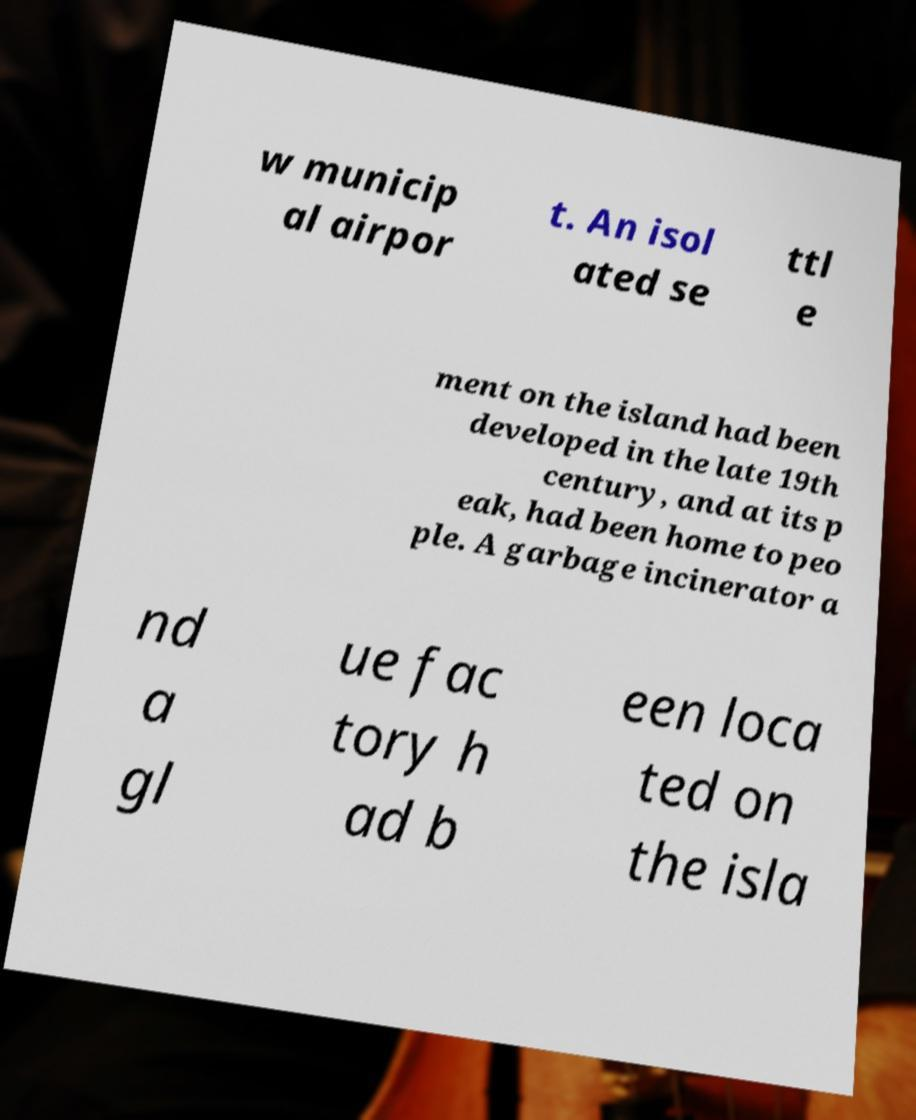Please read and relay the text visible in this image. What does it say? w municip al airpor t. An isol ated se ttl e ment on the island had been developed in the late 19th century, and at its p eak, had been home to peo ple. A garbage incinerator a nd a gl ue fac tory h ad b een loca ted on the isla 